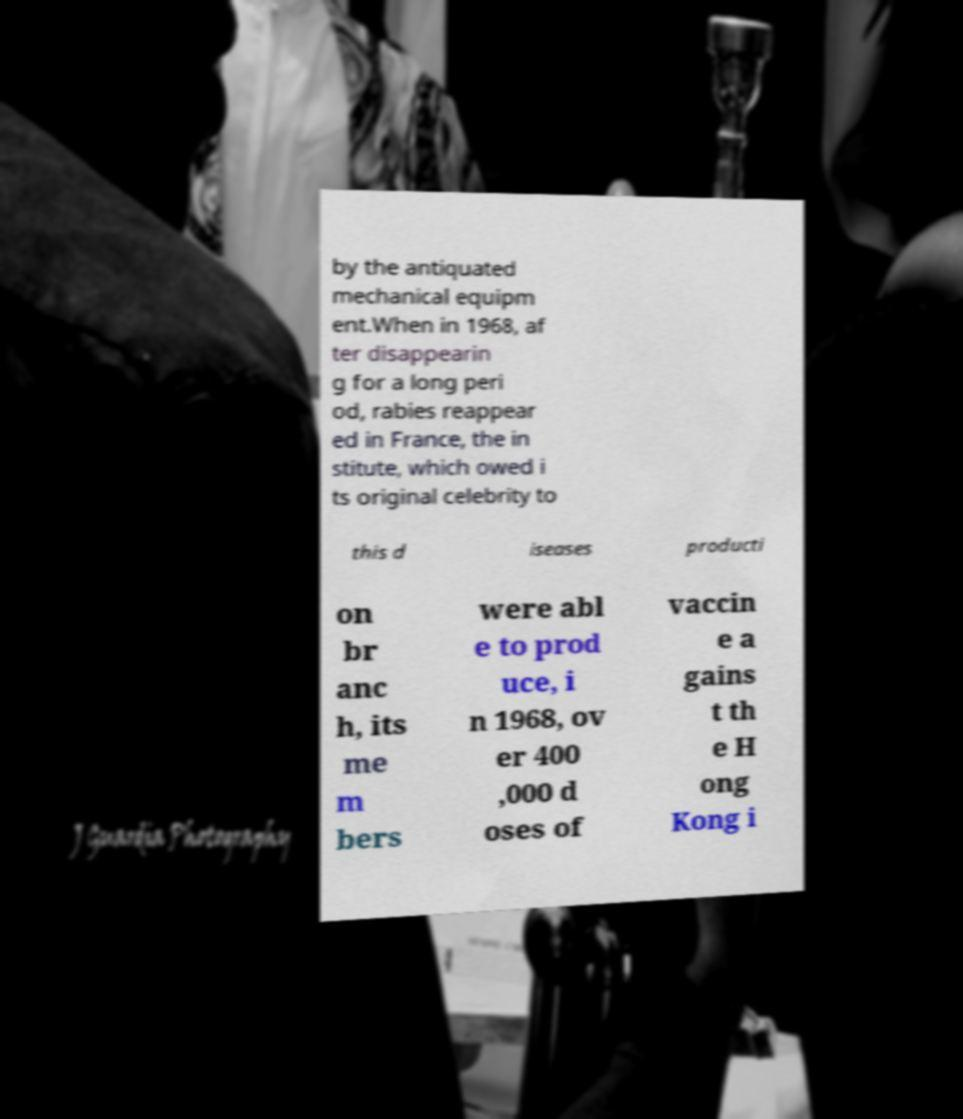What messages or text are displayed in this image? I need them in a readable, typed format. by the antiquated mechanical equipm ent.When in 1968, af ter disappearin g for a long peri od, rabies reappear ed in France, the in stitute, which owed i ts original celebrity to this d iseases producti on br anc h, its me m bers were abl e to prod uce, i n 1968, ov er 400 ,000 d oses of vaccin e a gains t th e H ong Kong i 